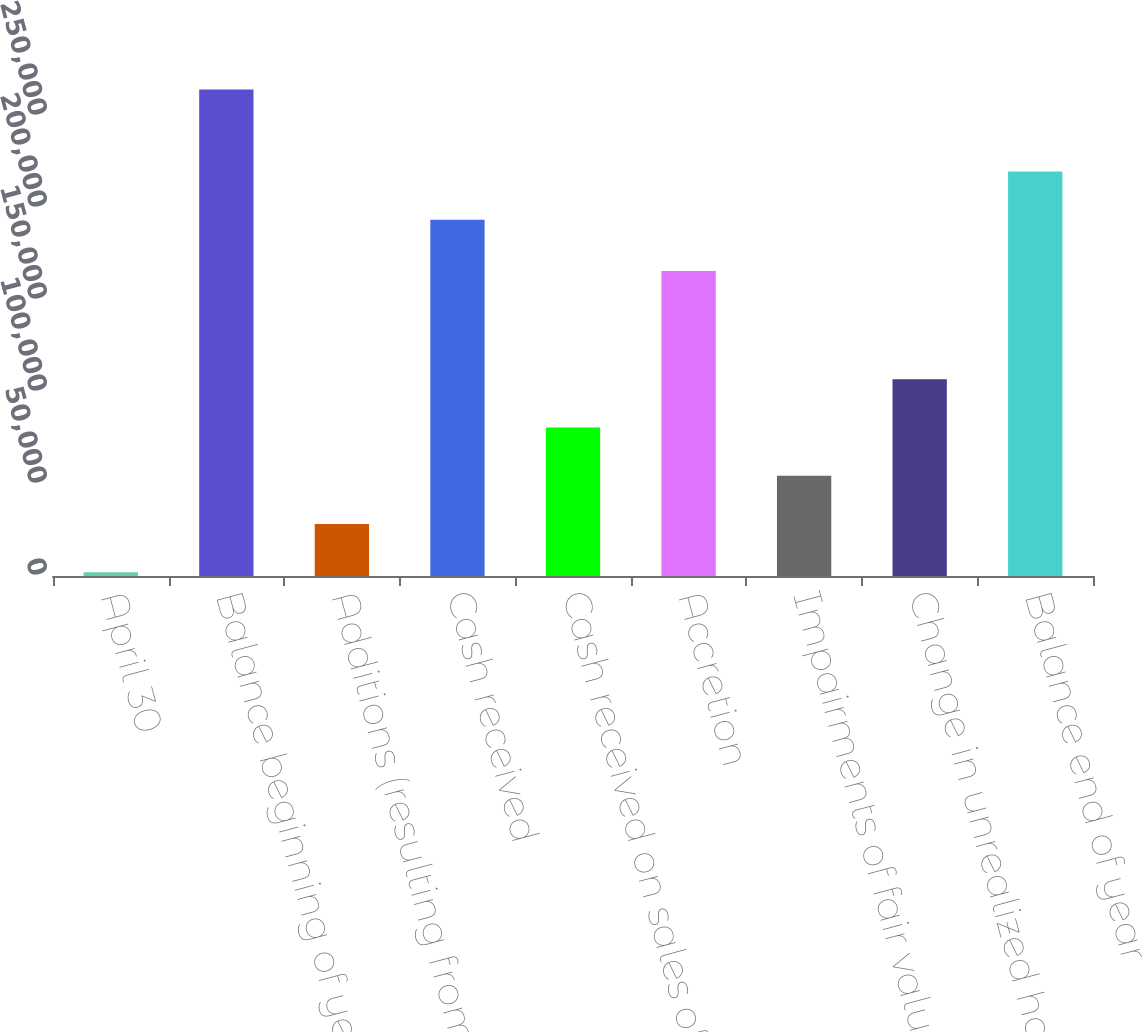Convert chart. <chart><loc_0><loc_0><loc_500><loc_500><bar_chart><fcel>April 30<fcel>Balance beginning of year<fcel>Additions (resulting from NIM<fcel>Cash received<fcel>Cash received on sales of<fcel>Accretion<fcel>Impairments of fair value<fcel>Change in unrealized holding<fcel>Balance end of year<nl><fcel>2004<fcel>264337<fcel>28237.3<fcel>193606<fcel>80703.9<fcel>165817<fcel>54470.6<fcel>106937<fcel>219839<nl></chart> 